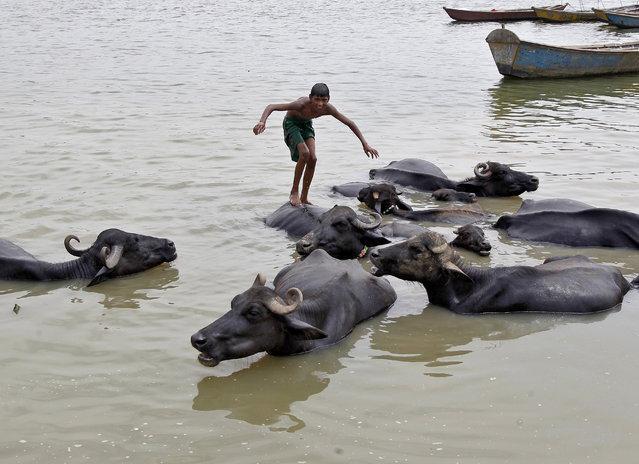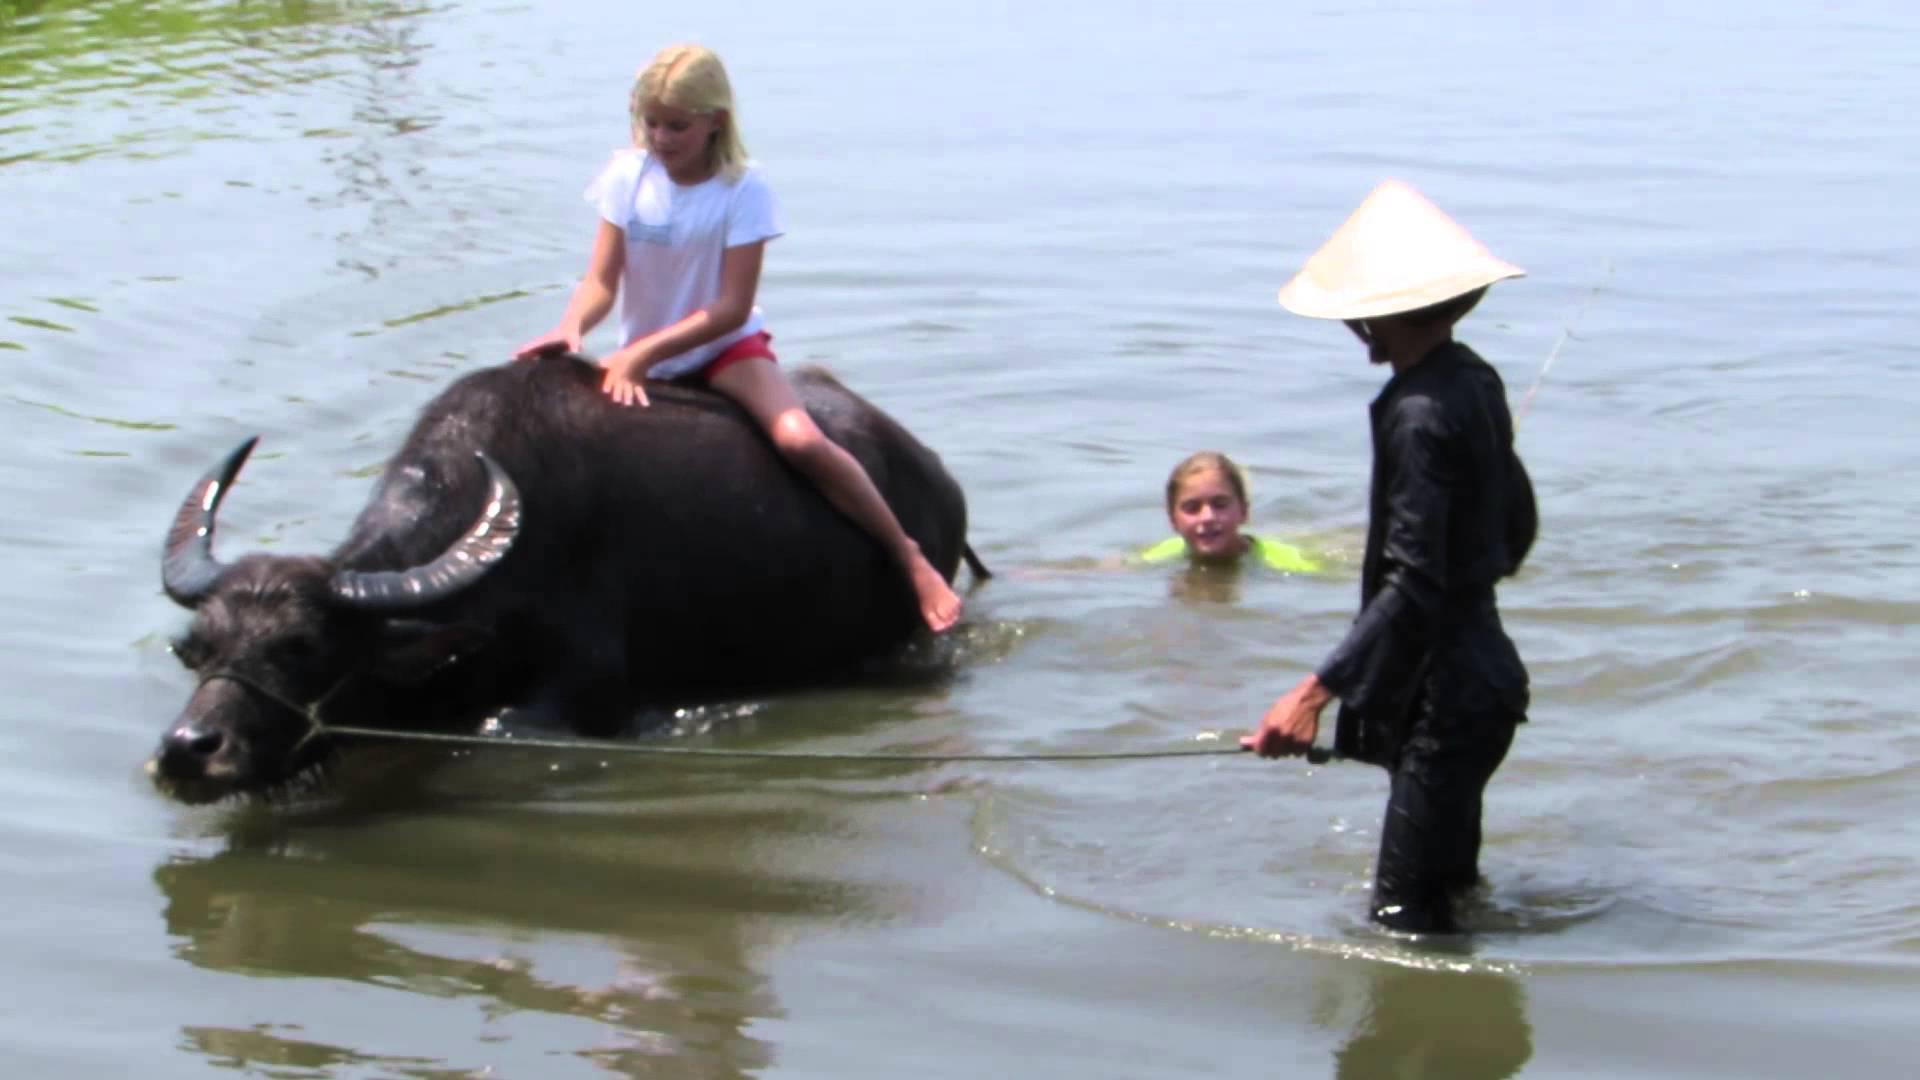The first image is the image on the left, the second image is the image on the right. Evaluate the accuracy of this statement regarding the images: "The right image contains no more than one water buffalo.". Is it true? Answer yes or no. Yes. The first image is the image on the left, the second image is the image on the right. Analyze the images presented: Is the assertion "One image shows a shirtless male standing in water and holding a hand toward a water buffalo in water to its neck." valid? Answer yes or no. No. 